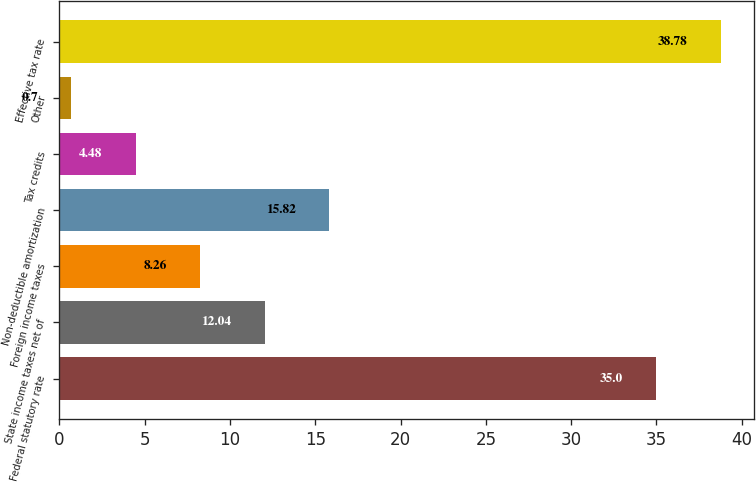Convert chart to OTSL. <chart><loc_0><loc_0><loc_500><loc_500><bar_chart><fcel>Federal statutory rate<fcel>State income taxes net of<fcel>Foreign income taxes<fcel>Non-deductible amortization<fcel>Tax credits<fcel>Other<fcel>Effective tax rate<nl><fcel>35<fcel>12.04<fcel>8.26<fcel>15.82<fcel>4.48<fcel>0.7<fcel>38.78<nl></chart> 